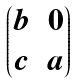Convert formula to latex. <formula><loc_0><loc_0><loc_500><loc_500>\begin{pmatrix} b & 0 \\ c & a \\ \end{pmatrix}</formula> 